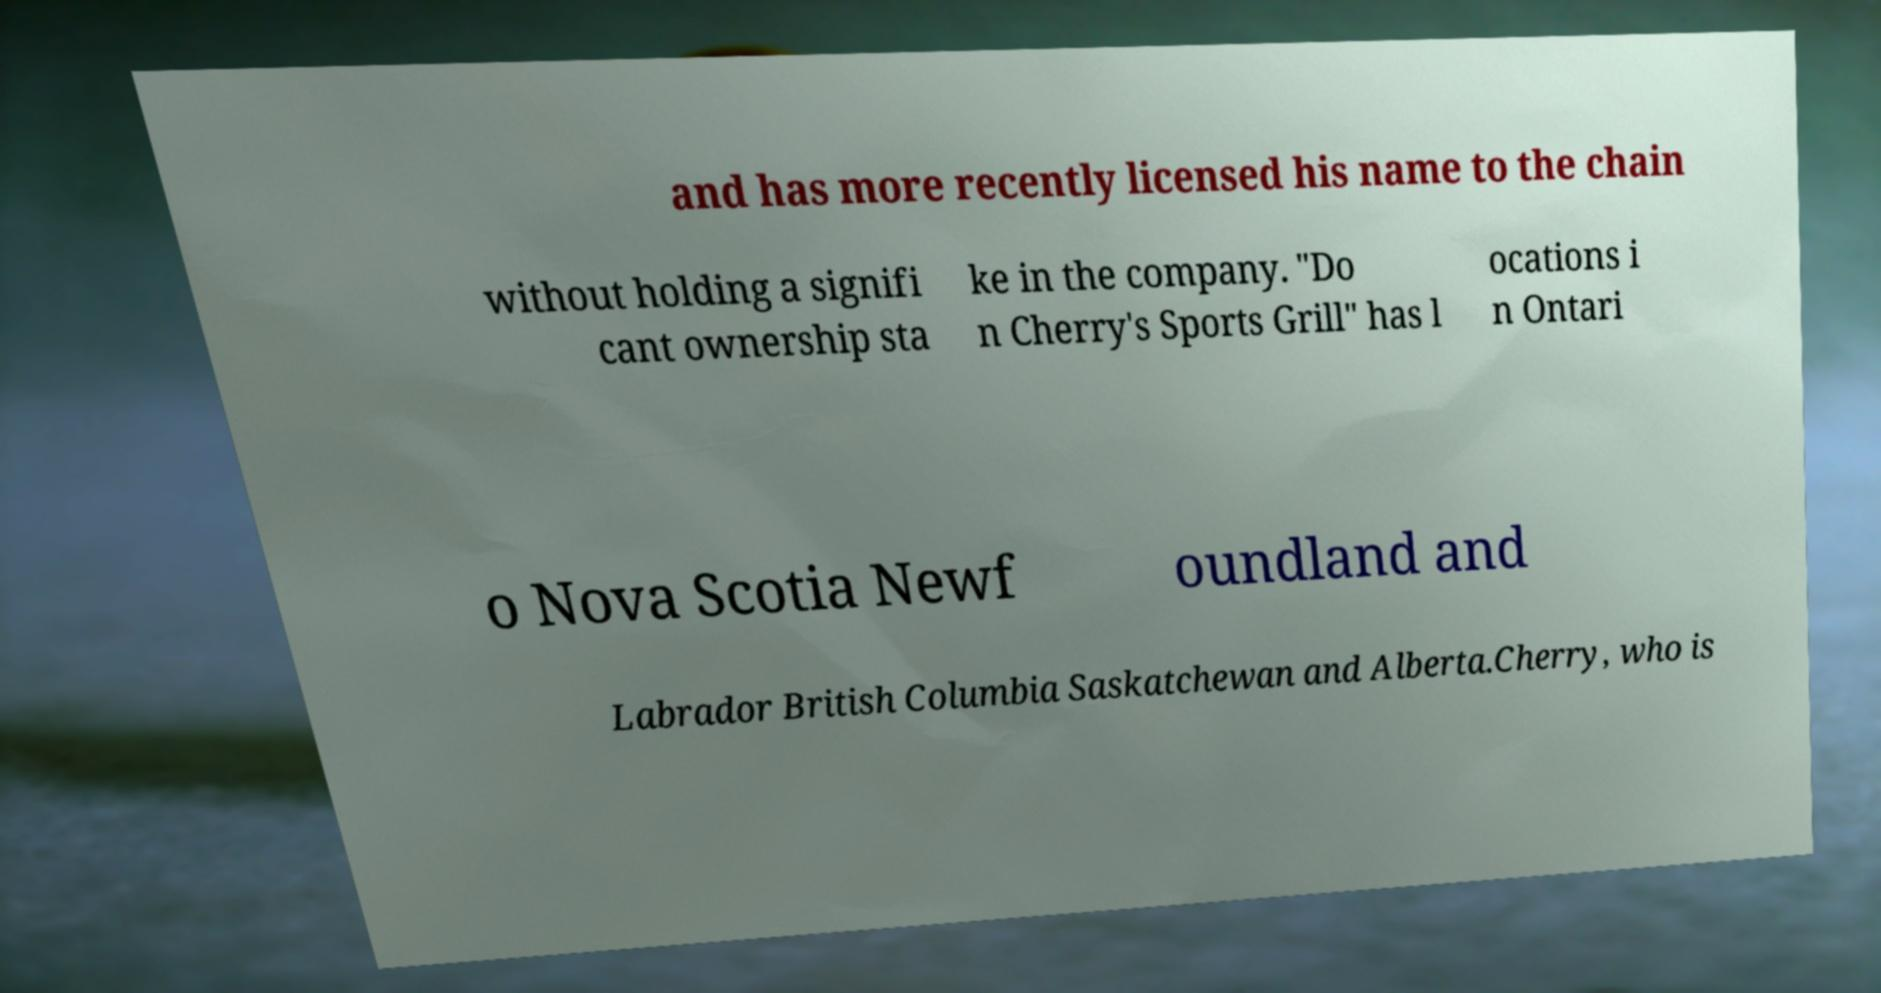There's text embedded in this image that I need extracted. Can you transcribe it verbatim? and has more recently licensed his name to the chain without holding a signifi cant ownership sta ke in the company. "Do n Cherry's Sports Grill" has l ocations i n Ontari o Nova Scotia Newf oundland and Labrador British Columbia Saskatchewan and Alberta.Cherry, who is 